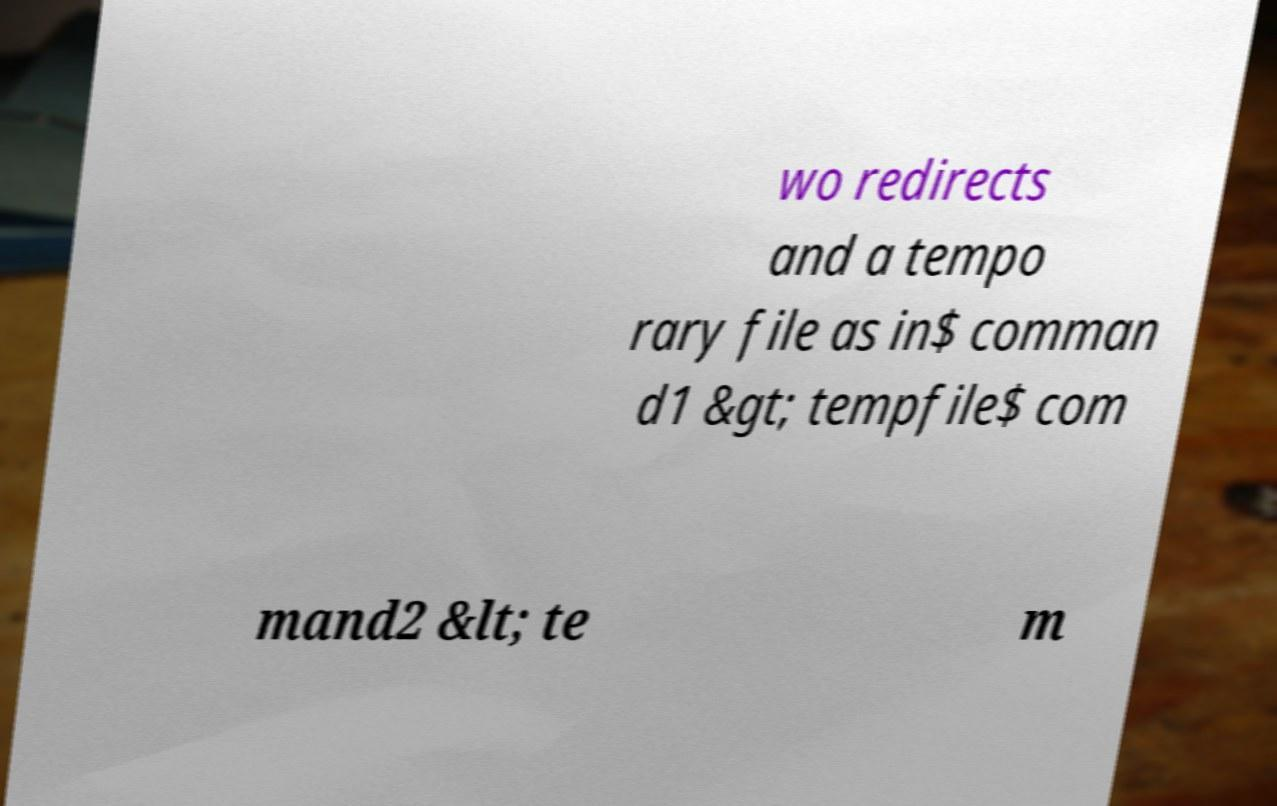I need the written content from this picture converted into text. Can you do that? wo redirects and a tempo rary file as in$ comman d1 &gt; tempfile$ com mand2 &lt; te m 